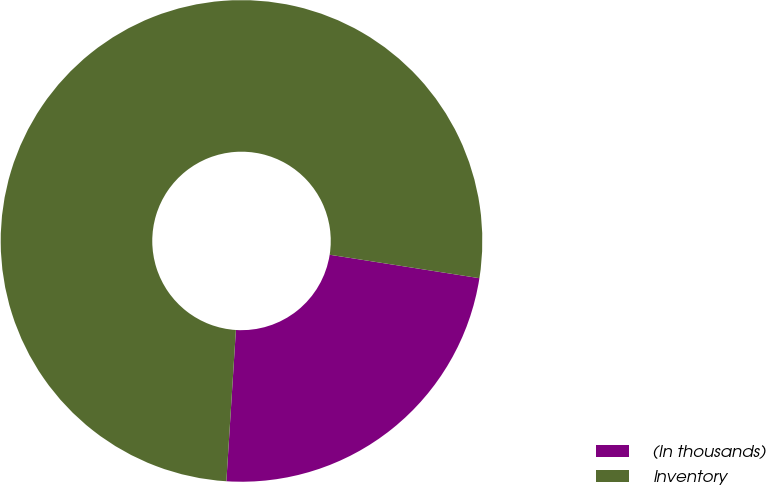<chart> <loc_0><loc_0><loc_500><loc_500><pie_chart><fcel>(In thousands)<fcel>Inventory<nl><fcel>23.53%<fcel>76.47%<nl></chart> 